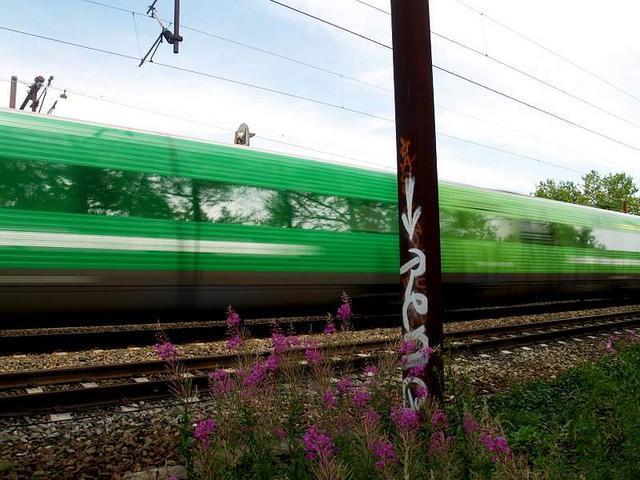How many people are standing on the floor?
Give a very brief answer. 0. 